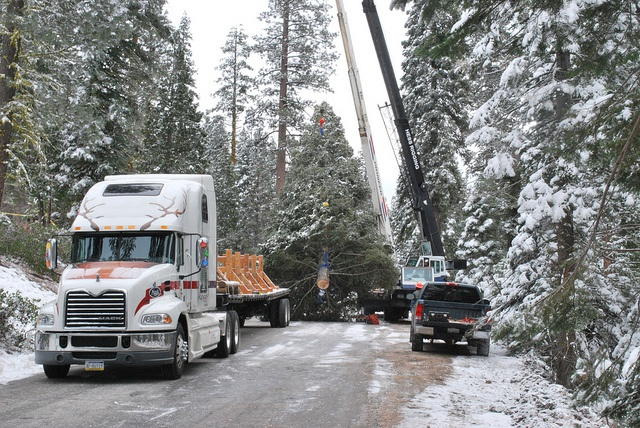Describe the objects in this image and their specific colors. I can see truck in dimgray, lightgray, black, darkgray, and gray tones, truck in dimgray, black, gray, and darkgray tones, and car in dimgray, gray, black, darkgray, and lightgray tones in this image. 